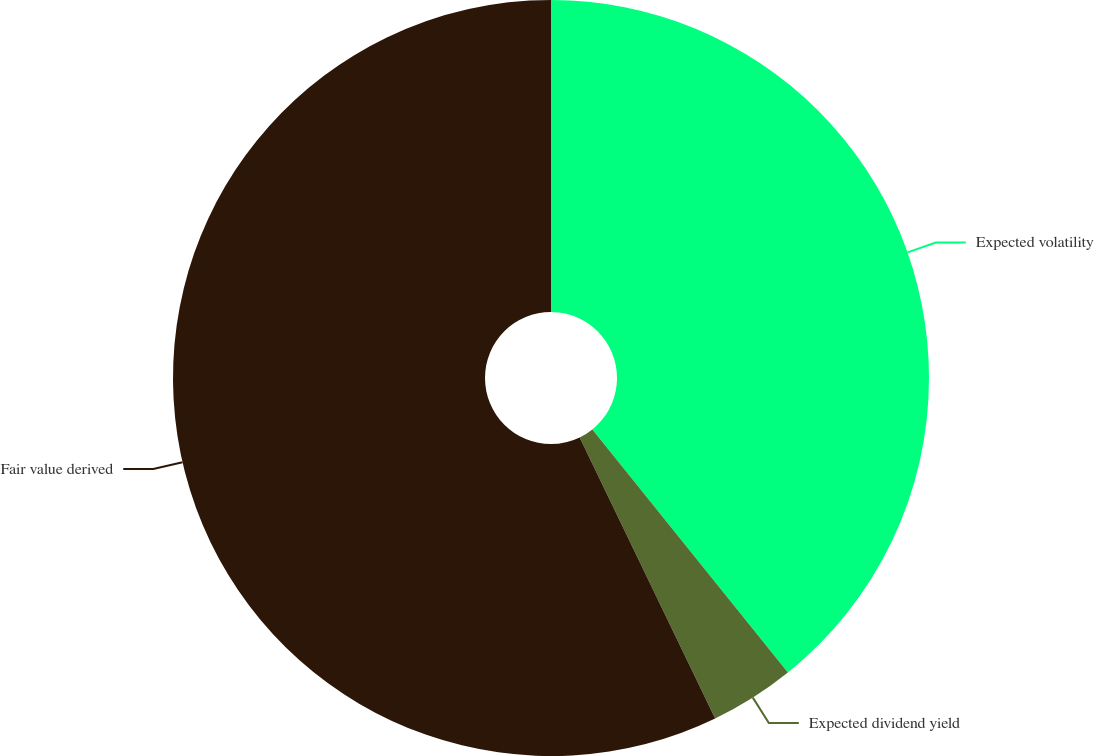<chart> <loc_0><loc_0><loc_500><loc_500><pie_chart><fcel>Expected volatility<fcel>Expected dividend yield<fcel>Fair value derived<nl><fcel>39.22%<fcel>3.63%<fcel>57.15%<nl></chart> 